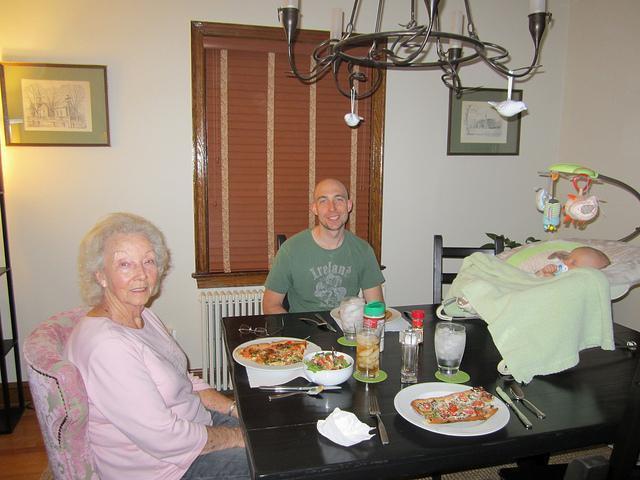What meal are the people most likely eating at the table?
Choose the correct response and explain in the format: 'Answer: answer
Rationale: rationale.'
Options: Dessert, breakfast, dinner, lunch. Answer: dinner.
Rationale: The people are eating a meal that consists of a flatbread dish and salad. these food items typically would not be served at breakfast or lunch. 